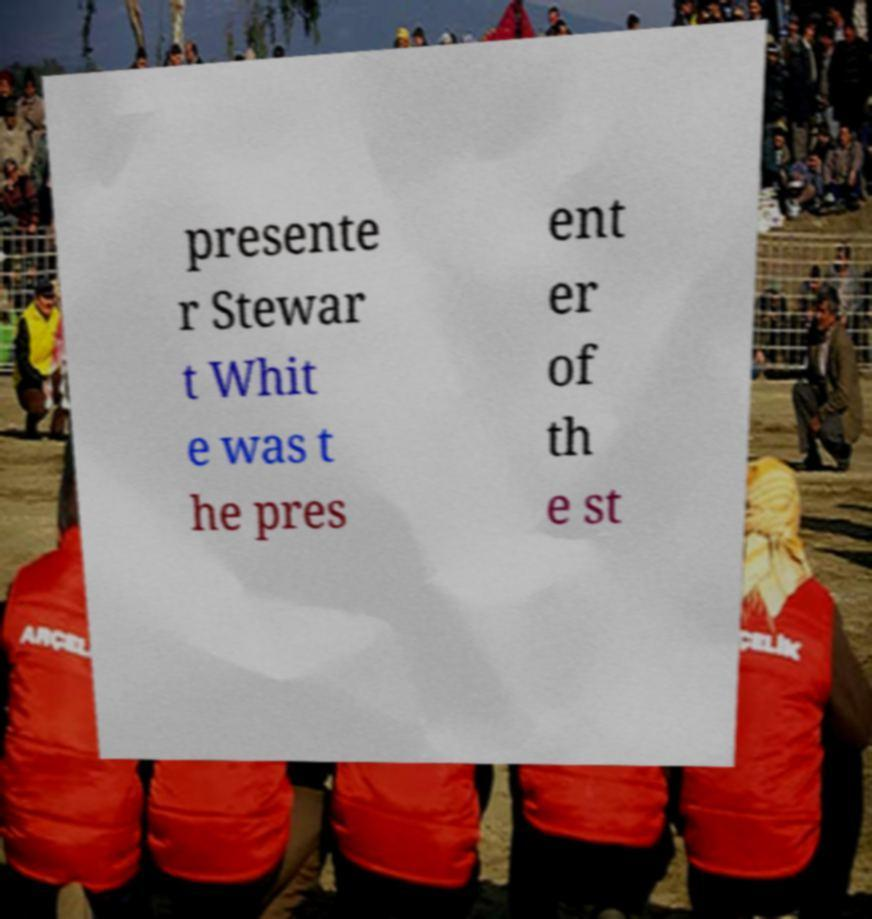What messages or text are displayed in this image? I need them in a readable, typed format. presente r Stewar t Whit e was t he pres ent er of th e st 